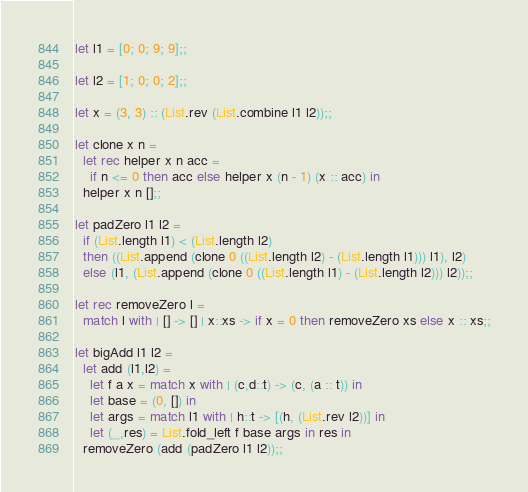<code> <loc_0><loc_0><loc_500><loc_500><_OCaml_>
let l1 = [0; 0; 9; 9];;

let l2 = [1; 0; 0; 2];;

let x = (3, 3) :: (List.rev (List.combine l1 l2));;

let clone x n =
  let rec helper x n acc =
    if n <= 0 then acc else helper x (n - 1) (x :: acc) in
  helper x n [];;

let padZero l1 l2 =
  if (List.length l1) < (List.length l2)
  then ((List.append (clone 0 ((List.length l2) - (List.length l1))) l1), l2)
  else (l1, (List.append (clone 0 ((List.length l1) - (List.length l2))) l2));;

let rec removeZero l =
  match l with | [] -> [] | x::xs -> if x = 0 then removeZero xs else x :: xs;;

let bigAdd l1 l2 =
  let add (l1,l2) =
    let f a x = match x with | (c,d::t) -> (c, (a :: t)) in
    let base = (0, []) in
    let args = match l1 with | h::t -> [(h, (List.rev l2))] in
    let (_,res) = List.fold_left f base args in res in
  removeZero (add (padZero l1 l2));;
</code> 